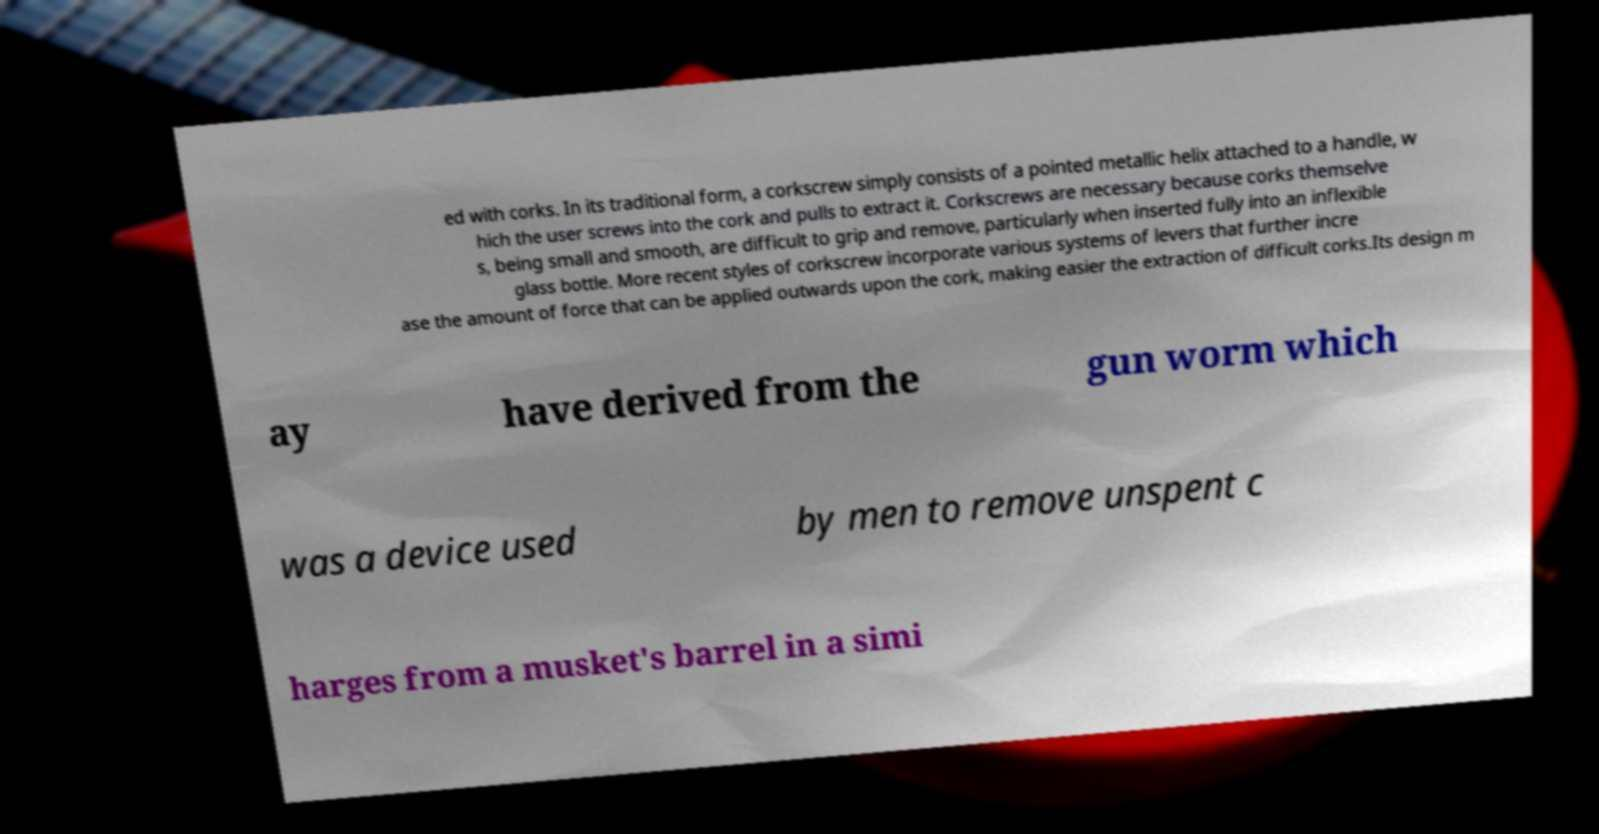For documentation purposes, I need the text within this image transcribed. Could you provide that? ed with corks. In its traditional form, a corkscrew simply consists of a pointed metallic helix attached to a handle, w hich the user screws into the cork and pulls to extract it. Corkscrews are necessary because corks themselve s, being small and smooth, are difficult to grip and remove, particularly when inserted fully into an inflexible glass bottle. More recent styles of corkscrew incorporate various systems of levers that further incre ase the amount of force that can be applied outwards upon the cork, making easier the extraction of difficult corks.Its design m ay have derived from the gun worm which was a device used by men to remove unspent c harges from a musket's barrel in a simi 